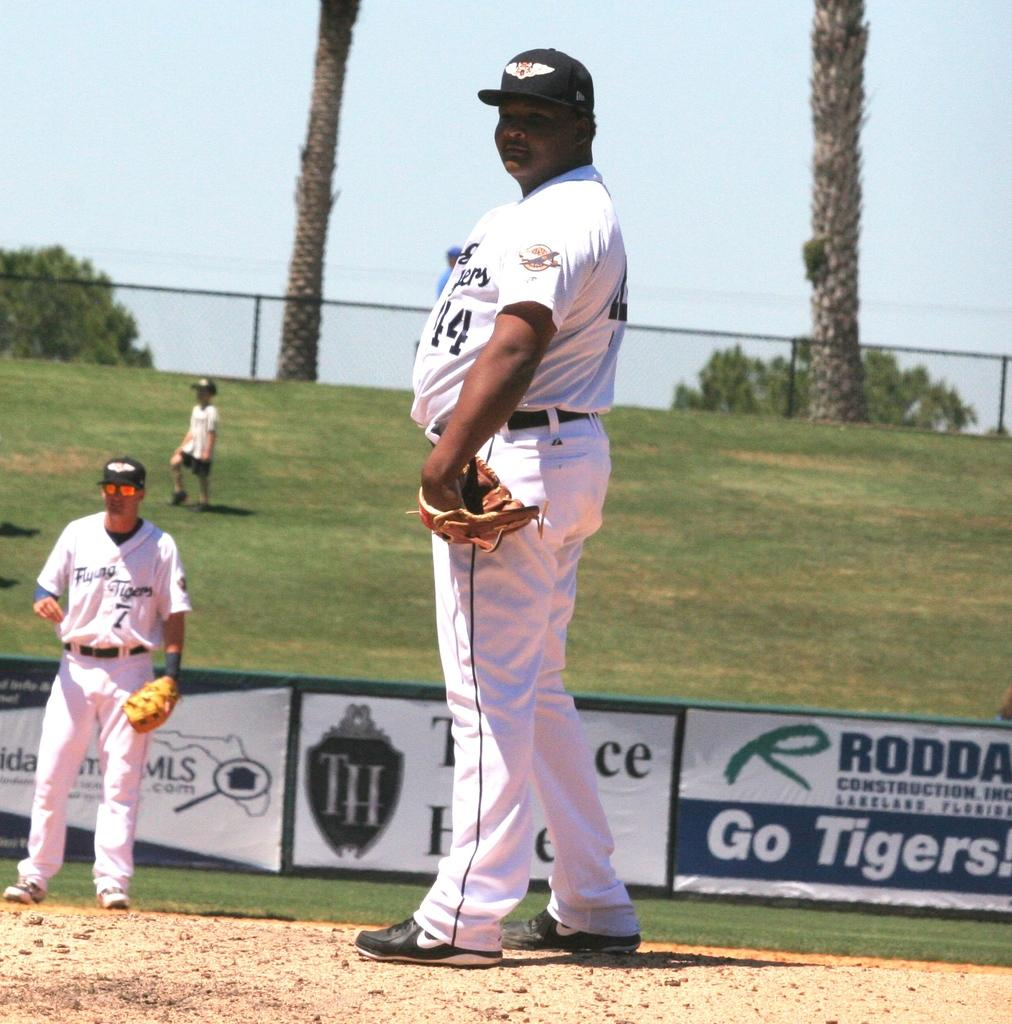<image>
Give a short and clear explanation of the subsequent image. Baseball player standing in front of a sign that says "Go Tigers". 